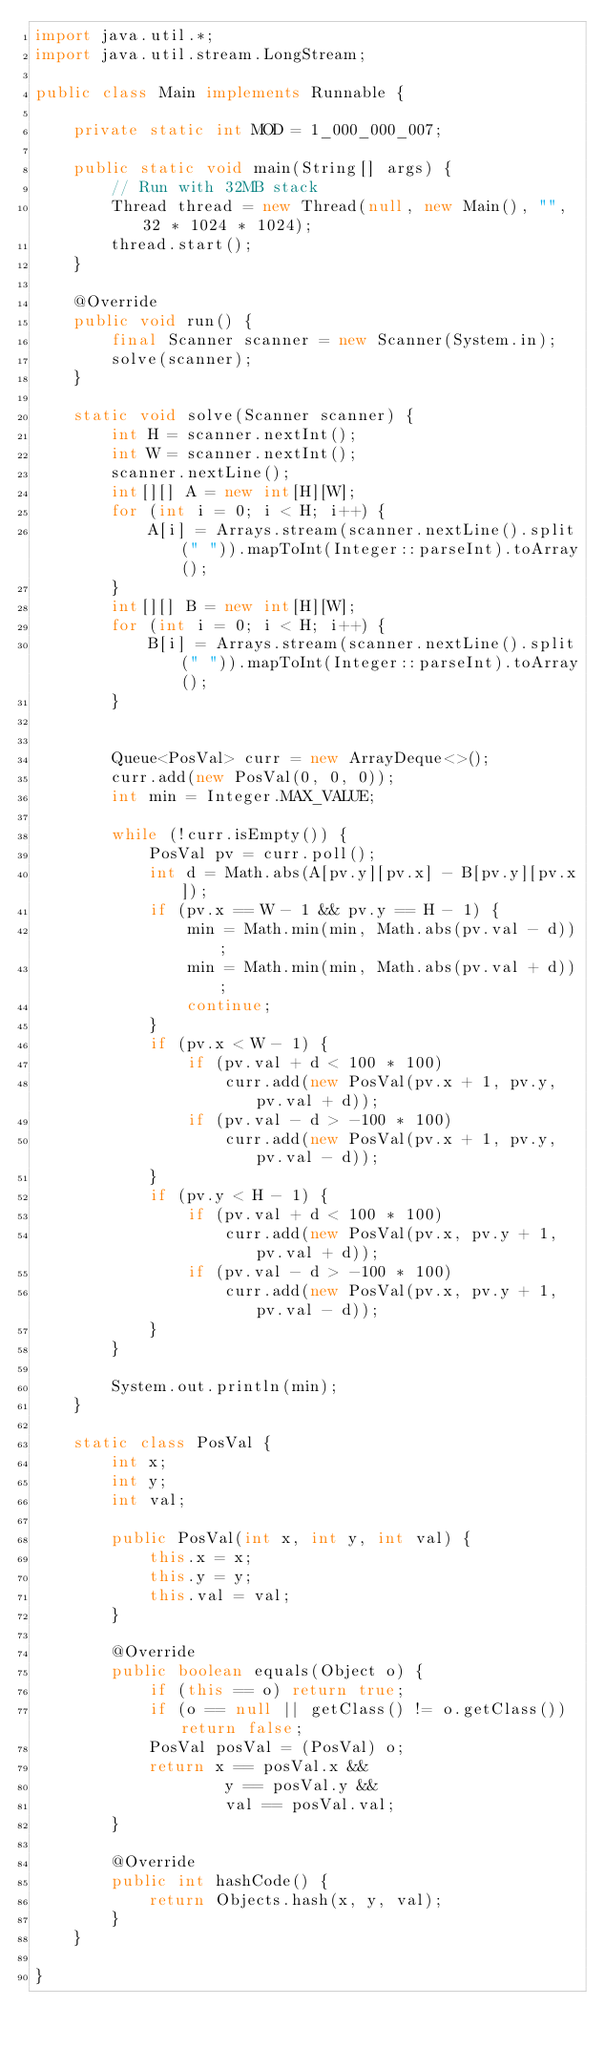<code> <loc_0><loc_0><loc_500><loc_500><_Java_>import java.util.*;
import java.util.stream.LongStream;

public class Main implements Runnable {

    private static int MOD = 1_000_000_007;

    public static void main(String[] args) {
        // Run with 32MB stack
        Thread thread = new Thread(null, new Main(), "", 32 * 1024 * 1024);
        thread.start();
    }

    @Override
    public void run() {
        final Scanner scanner = new Scanner(System.in);
        solve(scanner);
    }

    static void solve(Scanner scanner) {
        int H = scanner.nextInt();
        int W = scanner.nextInt();
        scanner.nextLine();
        int[][] A = new int[H][W];
        for (int i = 0; i < H; i++) {
            A[i] = Arrays.stream(scanner.nextLine().split(" ")).mapToInt(Integer::parseInt).toArray();
        }
        int[][] B = new int[H][W];
        for (int i = 0; i < H; i++) {
            B[i] = Arrays.stream(scanner.nextLine().split(" ")).mapToInt(Integer::parseInt).toArray();
        }


        Queue<PosVal> curr = new ArrayDeque<>();
        curr.add(new PosVal(0, 0, 0));
        int min = Integer.MAX_VALUE;

        while (!curr.isEmpty()) {
            PosVal pv = curr.poll();
            int d = Math.abs(A[pv.y][pv.x] - B[pv.y][pv.x]);
            if (pv.x == W - 1 && pv.y == H - 1) {
                min = Math.min(min, Math.abs(pv.val - d));
                min = Math.min(min, Math.abs(pv.val + d));
                continue;
            }
            if (pv.x < W - 1) {
                if (pv.val + d < 100 * 100)
                    curr.add(new PosVal(pv.x + 1, pv.y, pv.val + d));
                if (pv.val - d > -100 * 100)
                    curr.add(new PosVal(pv.x + 1, pv.y, pv.val - d));
            }
            if (pv.y < H - 1) {
                if (pv.val + d < 100 * 100)
                    curr.add(new PosVal(pv.x, pv.y + 1, pv.val + d));
                if (pv.val - d > -100 * 100)
                    curr.add(new PosVal(pv.x, pv.y + 1, pv.val - d));
            }
        }

        System.out.println(min);
    }

    static class PosVal {
        int x;
        int y;
        int val;

        public PosVal(int x, int y, int val) {
            this.x = x;
            this.y = y;
            this.val = val;
        }

        @Override
        public boolean equals(Object o) {
            if (this == o) return true;
            if (o == null || getClass() != o.getClass()) return false;
            PosVal posVal = (PosVal) o;
            return x == posVal.x &&
                    y == posVal.y &&
                    val == posVal.val;
        }

        @Override
        public int hashCode() {
            return Objects.hash(x, y, val);
        }
    }

}
</code> 